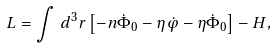Convert formula to latex. <formula><loc_0><loc_0><loc_500><loc_500>L = \int \, d ^ { 3 } r \left [ - n \dot { \Phi } _ { 0 } - \eta \dot { \varphi } - \eta \dot { \Phi } _ { 0 } \right ] - H ,</formula> 